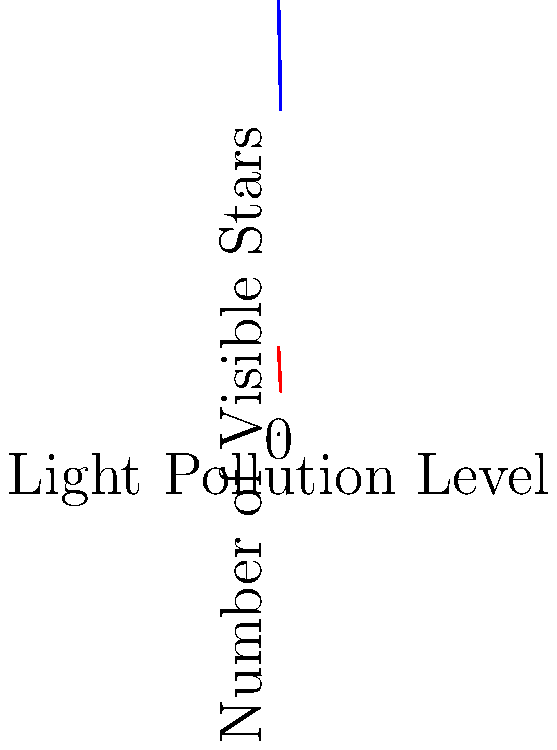Based on the graph showing the relationship between light pollution levels and the number of visible stars in rural and urban areas, what is the approximate percentage decrease in visible stars when moving from a rural area with no light pollution (level 0) to an urban area with the highest light pollution level (level 5)? To solve this problem, we need to follow these steps:

1. Identify the number of visible stars in rural areas at light pollution level 0:
   From the blue line (rural area), we can see that at x = 0, y ≈ 1000 stars

2. Identify the number of visible stars in urban areas at light pollution level 5:
   From the red line (urban area), we can see that at x = 5, y ≈ 100 stars

3. Calculate the percentage decrease using the formula:
   Percentage decrease = $\frac{\text{Decrease}}{\text{Original Value}} \times 100\%$

   Where:
   Decrease = Original Value - New Value
   Original Value = 1000 stars
   New Value = 100 stars

4. Plug in the values:
   Percentage decrease = $\frac{1000 - 100}{1000} \times 100\%$
                       = $\frac{900}{1000} \times 100\%$
                       = $0.9 \times 100\%$
                       = $90\%$

Therefore, the approximate percentage decrease in visible stars when moving from a rural area with no light pollution to an urban area with the highest light pollution level is 90%.
Answer: 90% 